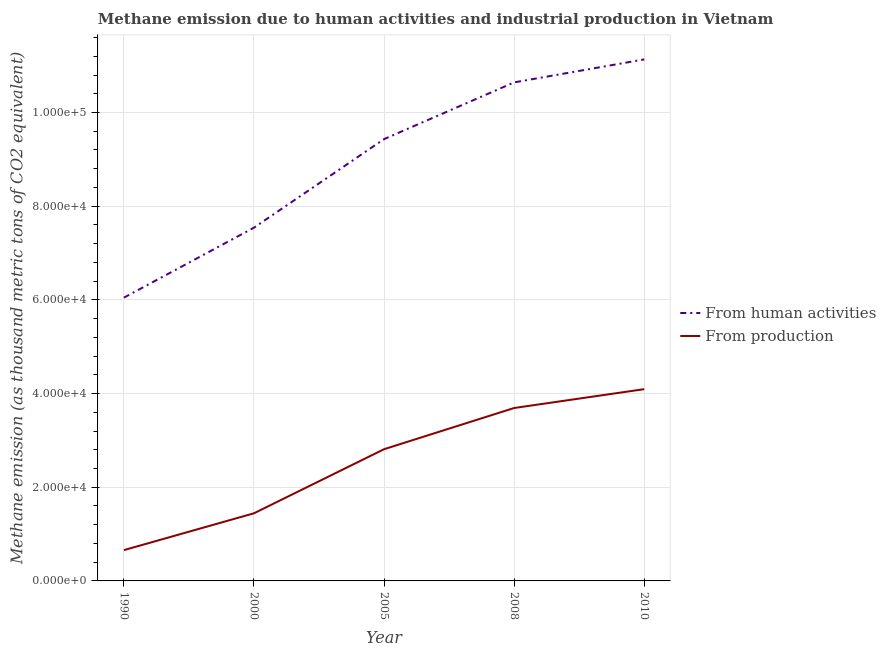Does the line corresponding to amount of emissions generated from industries intersect with the line corresponding to amount of emissions from human activities?
Keep it short and to the point. No. What is the amount of emissions from human activities in 2010?
Your answer should be compact. 1.11e+05. Across all years, what is the maximum amount of emissions generated from industries?
Offer a very short reply. 4.09e+04. Across all years, what is the minimum amount of emissions from human activities?
Provide a short and direct response. 6.05e+04. In which year was the amount of emissions from human activities maximum?
Ensure brevity in your answer.  2010. What is the total amount of emissions generated from industries in the graph?
Give a very brief answer. 1.27e+05. What is the difference between the amount of emissions from human activities in 1990 and that in 2005?
Offer a terse response. -3.39e+04. What is the difference between the amount of emissions generated from industries in 2010 and the amount of emissions from human activities in 2008?
Provide a succinct answer. -6.55e+04. What is the average amount of emissions from human activities per year?
Ensure brevity in your answer.  8.96e+04. In the year 2005, what is the difference between the amount of emissions from human activities and amount of emissions generated from industries?
Ensure brevity in your answer.  6.62e+04. What is the ratio of the amount of emissions from human activities in 1990 to that in 2008?
Give a very brief answer. 0.57. Is the difference between the amount of emissions generated from industries in 1990 and 2000 greater than the difference between the amount of emissions from human activities in 1990 and 2000?
Provide a succinct answer. Yes. What is the difference between the highest and the second highest amount of emissions from human activities?
Keep it short and to the point. 4904.7. What is the difference between the highest and the lowest amount of emissions from human activities?
Provide a short and direct response. 5.09e+04. In how many years, is the amount of emissions from human activities greater than the average amount of emissions from human activities taken over all years?
Provide a short and direct response. 3. Does the amount of emissions generated from industries monotonically increase over the years?
Your response must be concise. Yes. Is the amount of emissions generated from industries strictly less than the amount of emissions from human activities over the years?
Your answer should be very brief. Yes. Does the graph contain grids?
Offer a very short reply. Yes. How many legend labels are there?
Provide a succinct answer. 2. What is the title of the graph?
Your response must be concise. Methane emission due to human activities and industrial production in Vietnam. Does "Secondary Education" appear as one of the legend labels in the graph?
Ensure brevity in your answer.  No. What is the label or title of the X-axis?
Offer a very short reply. Year. What is the label or title of the Y-axis?
Offer a very short reply. Methane emission (as thousand metric tons of CO2 equivalent). What is the Methane emission (as thousand metric tons of CO2 equivalent) of From human activities in 1990?
Your response must be concise. 6.05e+04. What is the Methane emission (as thousand metric tons of CO2 equivalent) of From production in 1990?
Offer a very short reply. 6574.5. What is the Methane emission (as thousand metric tons of CO2 equivalent) in From human activities in 2000?
Provide a short and direct response. 7.54e+04. What is the Methane emission (as thousand metric tons of CO2 equivalent) of From production in 2000?
Your answer should be compact. 1.44e+04. What is the Methane emission (as thousand metric tons of CO2 equivalent) in From human activities in 2005?
Your answer should be very brief. 9.43e+04. What is the Methane emission (as thousand metric tons of CO2 equivalent) of From production in 2005?
Provide a succinct answer. 2.81e+04. What is the Methane emission (as thousand metric tons of CO2 equivalent) in From human activities in 2008?
Give a very brief answer. 1.06e+05. What is the Methane emission (as thousand metric tons of CO2 equivalent) in From production in 2008?
Provide a short and direct response. 3.69e+04. What is the Methane emission (as thousand metric tons of CO2 equivalent) of From human activities in 2010?
Make the answer very short. 1.11e+05. What is the Methane emission (as thousand metric tons of CO2 equivalent) in From production in 2010?
Make the answer very short. 4.09e+04. Across all years, what is the maximum Methane emission (as thousand metric tons of CO2 equivalent) of From human activities?
Offer a very short reply. 1.11e+05. Across all years, what is the maximum Methane emission (as thousand metric tons of CO2 equivalent) in From production?
Offer a terse response. 4.09e+04. Across all years, what is the minimum Methane emission (as thousand metric tons of CO2 equivalent) of From human activities?
Ensure brevity in your answer.  6.05e+04. Across all years, what is the minimum Methane emission (as thousand metric tons of CO2 equivalent) of From production?
Keep it short and to the point. 6574.5. What is the total Methane emission (as thousand metric tons of CO2 equivalent) of From human activities in the graph?
Make the answer very short. 4.48e+05. What is the total Methane emission (as thousand metric tons of CO2 equivalent) in From production in the graph?
Offer a very short reply. 1.27e+05. What is the difference between the Methane emission (as thousand metric tons of CO2 equivalent) in From human activities in 1990 and that in 2000?
Provide a succinct answer. -1.49e+04. What is the difference between the Methane emission (as thousand metric tons of CO2 equivalent) of From production in 1990 and that in 2000?
Your answer should be compact. -7863.6. What is the difference between the Methane emission (as thousand metric tons of CO2 equivalent) of From human activities in 1990 and that in 2005?
Offer a very short reply. -3.39e+04. What is the difference between the Methane emission (as thousand metric tons of CO2 equivalent) in From production in 1990 and that in 2005?
Keep it short and to the point. -2.15e+04. What is the difference between the Methane emission (as thousand metric tons of CO2 equivalent) of From human activities in 1990 and that in 2008?
Your answer should be compact. -4.60e+04. What is the difference between the Methane emission (as thousand metric tons of CO2 equivalent) in From production in 1990 and that in 2008?
Offer a very short reply. -3.03e+04. What is the difference between the Methane emission (as thousand metric tons of CO2 equivalent) of From human activities in 1990 and that in 2010?
Make the answer very short. -5.09e+04. What is the difference between the Methane emission (as thousand metric tons of CO2 equivalent) of From production in 1990 and that in 2010?
Your answer should be compact. -3.44e+04. What is the difference between the Methane emission (as thousand metric tons of CO2 equivalent) of From human activities in 2000 and that in 2005?
Ensure brevity in your answer.  -1.89e+04. What is the difference between the Methane emission (as thousand metric tons of CO2 equivalent) of From production in 2000 and that in 2005?
Your answer should be very brief. -1.37e+04. What is the difference between the Methane emission (as thousand metric tons of CO2 equivalent) in From human activities in 2000 and that in 2008?
Make the answer very short. -3.10e+04. What is the difference between the Methane emission (as thousand metric tons of CO2 equivalent) in From production in 2000 and that in 2008?
Your answer should be very brief. -2.25e+04. What is the difference between the Methane emission (as thousand metric tons of CO2 equivalent) in From human activities in 2000 and that in 2010?
Offer a terse response. -3.59e+04. What is the difference between the Methane emission (as thousand metric tons of CO2 equivalent) of From production in 2000 and that in 2010?
Ensure brevity in your answer.  -2.65e+04. What is the difference between the Methane emission (as thousand metric tons of CO2 equivalent) of From human activities in 2005 and that in 2008?
Ensure brevity in your answer.  -1.21e+04. What is the difference between the Methane emission (as thousand metric tons of CO2 equivalent) in From production in 2005 and that in 2008?
Make the answer very short. -8796. What is the difference between the Methane emission (as thousand metric tons of CO2 equivalent) of From human activities in 2005 and that in 2010?
Offer a very short reply. -1.70e+04. What is the difference between the Methane emission (as thousand metric tons of CO2 equivalent) of From production in 2005 and that in 2010?
Ensure brevity in your answer.  -1.28e+04. What is the difference between the Methane emission (as thousand metric tons of CO2 equivalent) in From human activities in 2008 and that in 2010?
Make the answer very short. -4904.7. What is the difference between the Methane emission (as thousand metric tons of CO2 equivalent) of From production in 2008 and that in 2010?
Your response must be concise. -4024.6. What is the difference between the Methane emission (as thousand metric tons of CO2 equivalent) of From human activities in 1990 and the Methane emission (as thousand metric tons of CO2 equivalent) of From production in 2000?
Ensure brevity in your answer.  4.60e+04. What is the difference between the Methane emission (as thousand metric tons of CO2 equivalent) of From human activities in 1990 and the Methane emission (as thousand metric tons of CO2 equivalent) of From production in 2005?
Offer a very short reply. 3.24e+04. What is the difference between the Methane emission (as thousand metric tons of CO2 equivalent) of From human activities in 1990 and the Methane emission (as thousand metric tons of CO2 equivalent) of From production in 2008?
Your answer should be very brief. 2.36e+04. What is the difference between the Methane emission (as thousand metric tons of CO2 equivalent) in From human activities in 1990 and the Methane emission (as thousand metric tons of CO2 equivalent) in From production in 2010?
Ensure brevity in your answer.  1.95e+04. What is the difference between the Methane emission (as thousand metric tons of CO2 equivalent) in From human activities in 2000 and the Methane emission (as thousand metric tons of CO2 equivalent) in From production in 2005?
Your answer should be very brief. 4.73e+04. What is the difference between the Methane emission (as thousand metric tons of CO2 equivalent) of From human activities in 2000 and the Methane emission (as thousand metric tons of CO2 equivalent) of From production in 2008?
Offer a terse response. 3.85e+04. What is the difference between the Methane emission (as thousand metric tons of CO2 equivalent) in From human activities in 2000 and the Methane emission (as thousand metric tons of CO2 equivalent) in From production in 2010?
Make the answer very short. 3.45e+04. What is the difference between the Methane emission (as thousand metric tons of CO2 equivalent) in From human activities in 2005 and the Methane emission (as thousand metric tons of CO2 equivalent) in From production in 2008?
Provide a short and direct response. 5.74e+04. What is the difference between the Methane emission (as thousand metric tons of CO2 equivalent) in From human activities in 2005 and the Methane emission (as thousand metric tons of CO2 equivalent) in From production in 2010?
Your answer should be very brief. 5.34e+04. What is the difference between the Methane emission (as thousand metric tons of CO2 equivalent) of From human activities in 2008 and the Methane emission (as thousand metric tons of CO2 equivalent) of From production in 2010?
Your response must be concise. 6.55e+04. What is the average Methane emission (as thousand metric tons of CO2 equivalent) in From human activities per year?
Provide a short and direct response. 8.96e+04. What is the average Methane emission (as thousand metric tons of CO2 equivalent) in From production per year?
Offer a terse response. 2.54e+04. In the year 1990, what is the difference between the Methane emission (as thousand metric tons of CO2 equivalent) in From human activities and Methane emission (as thousand metric tons of CO2 equivalent) in From production?
Your answer should be compact. 5.39e+04. In the year 2000, what is the difference between the Methane emission (as thousand metric tons of CO2 equivalent) of From human activities and Methane emission (as thousand metric tons of CO2 equivalent) of From production?
Offer a terse response. 6.10e+04. In the year 2005, what is the difference between the Methane emission (as thousand metric tons of CO2 equivalent) in From human activities and Methane emission (as thousand metric tons of CO2 equivalent) in From production?
Your response must be concise. 6.62e+04. In the year 2008, what is the difference between the Methane emission (as thousand metric tons of CO2 equivalent) of From human activities and Methane emission (as thousand metric tons of CO2 equivalent) of From production?
Offer a very short reply. 6.95e+04. In the year 2010, what is the difference between the Methane emission (as thousand metric tons of CO2 equivalent) of From human activities and Methane emission (as thousand metric tons of CO2 equivalent) of From production?
Your response must be concise. 7.04e+04. What is the ratio of the Methane emission (as thousand metric tons of CO2 equivalent) of From human activities in 1990 to that in 2000?
Give a very brief answer. 0.8. What is the ratio of the Methane emission (as thousand metric tons of CO2 equivalent) in From production in 1990 to that in 2000?
Give a very brief answer. 0.46. What is the ratio of the Methane emission (as thousand metric tons of CO2 equivalent) in From human activities in 1990 to that in 2005?
Give a very brief answer. 0.64. What is the ratio of the Methane emission (as thousand metric tons of CO2 equivalent) in From production in 1990 to that in 2005?
Your response must be concise. 0.23. What is the ratio of the Methane emission (as thousand metric tons of CO2 equivalent) in From human activities in 1990 to that in 2008?
Ensure brevity in your answer.  0.57. What is the ratio of the Methane emission (as thousand metric tons of CO2 equivalent) in From production in 1990 to that in 2008?
Keep it short and to the point. 0.18. What is the ratio of the Methane emission (as thousand metric tons of CO2 equivalent) of From human activities in 1990 to that in 2010?
Your response must be concise. 0.54. What is the ratio of the Methane emission (as thousand metric tons of CO2 equivalent) in From production in 1990 to that in 2010?
Make the answer very short. 0.16. What is the ratio of the Methane emission (as thousand metric tons of CO2 equivalent) in From human activities in 2000 to that in 2005?
Your answer should be very brief. 0.8. What is the ratio of the Methane emission (as thousand metric tons of CO2 equivalent) of From production in 2000 to that in 2005?
Give a very brief answer. 0.51. What is the ratio of the Methane emission (as thousand metric tons of CO2 equivalent) of From human activities in 2000 to that in 2008?
Give a very brief answer. 0.71. What is the ratio of the Methane emission (as thousand metric tons of CO2 equivalent) in From production in 2000 to that in 2008?
Your answer should be compact. 0.39. What is the ratio of the Methane emission (as thousand metric tons of CO2 equivalent) in From human activities in 2000 to that in 2010?
Make the answer very short. 0.68. What is the ratio of the Methane emission (as thousand metric tons of CO2 equivalent) in From production in 2000 to that in 2010?
Your response must be concise. 0.35. What is the ratio of the Methane emission (as thousand metric tons of CO2 equivalent) in From human activities in 2005 to that in 2008?
Your answer should be compact. 0.89. What is the ratio of the Methane emission (as thousand metric tons of CO2 equivalent) in From production in 2005 to that in 2008?
Keep it short and to the point. 0.76. What is the ratio of the Methane emission (as thousand metric tons of CO2 equivalent) in From human activities in 2005 to that in 2010?
Offer a terse response. 0.85. What is the ratio of the Methane emission (as thousand metric tons of CO2 equivalent) of From production in 2005 to that in 2010?
Give a very brief answer. 0.69. What is the ratio of the Methane emission (as thousand metric tons of CO2 equivalent) of From human activities in 2008 to that in 2010?
Your answer should be compact. 0.96. What is the ratio of the Methane emission (as thousand metric tons of CO2 equivalent) in From production in 2008 to that in 2010?
Keep it short and to the point. 0.9. What is the difference between the highest and the second highest Methane emission (as thousand metric tons of CO2 equivalent) in From human activities?
Provide a short and direct response. 4904.7. What is the difference between the highest and the second highest Methane emission (as thousand metric tons of CO2 equivalent) in From production?
Keep it short and to the point. 4024.6. What is the difference between the highest and the lowest Methane emission (as thousand metric tons of CO2 equivalent) of From human activities?
Offer a terse response. 5.09e+04. What is the difference between the highest and the lowest Methane emission (as thousand metric tons of CO2 equivalent) in From production?
Provide a short and direct response. 3.44e+04. 